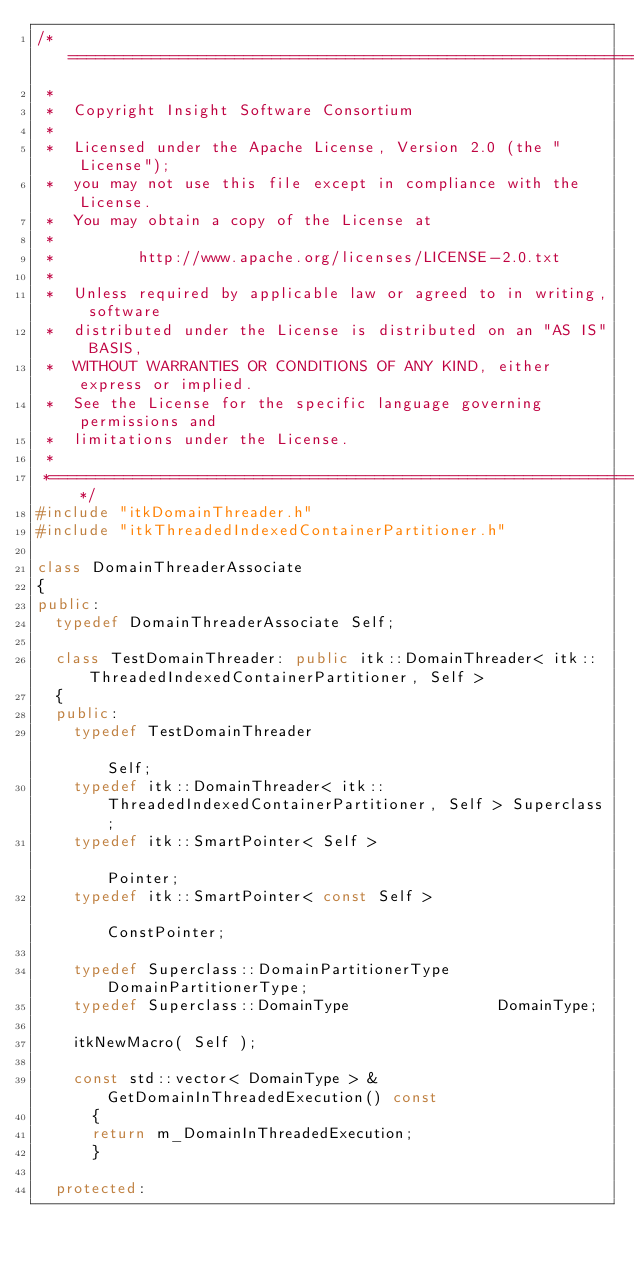<code> <loc_0><loc_0><loc_500><loc_500><_C++_>/*=========================================================================
 *
 *  Copyright Insight Software Consortium
 *
 *  Licensed under the Apache License, Version 2.0 (the "License");
 *  you may not use this file except in compliance with the License.
 *  You may obtain a copy of the License at
 *
 *         http://www.apache.org/licenses/LICENSE-2.0.txt
 *
 *  Unless required by applicable law or agreed to in writing, software
 *  distributed under the License is distributed on an "AS IS" BASIS,
 *  WITHOUT WARRANTIES OR CONDITIONS OF ANY KIND, either express or implied.
 *  See the License for the specific language governing permissions and
 *  limitations under the License.
 *
 *=========================================================================*/
#include "itkDomainThreader.h"
#include "itkThreadedIndexedContainerPartitioner.h"

class DomainThreaderAssociate
{
public:
  typedef DomainThreaderAssociate Self;

  class TestDomainThreader: public itk::DomainThreader< itk::ThreadedIndexedContainerPartitioner, Self >
  {
  public:
    typedef TestDomainThreader                                                                            Self;
    typedef itk::DomainThreader< itk::ThreadedIndexedContainerPartitioner, Self > Superclass;
    typedef itk::SmartPointer< Self >                                                                     Pointer;
    typedef itk::SmartPointer< const Self >                                                               ConstPointer;

    typedef Superclass::DomainPartitionerType     DomainPartitionerType;
    typedef Superclass::DomainType                DomainType;

    itkNewMacro( Self );

    const std::vector< DomainType > & GetDomainInThreadedExecution() const
      {
      return m_DomainInThreadedExecution;
      }

  protected:</code> 